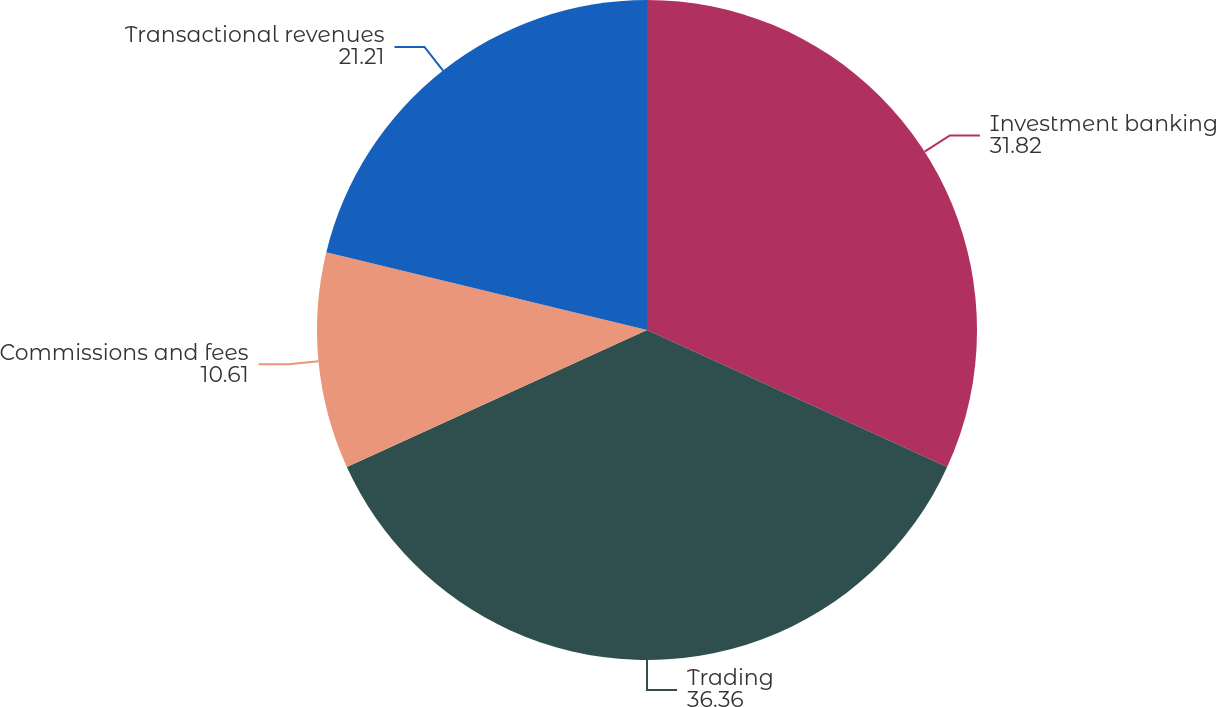Convert chart. <chart><loc_0><loc_0><loc_500><loc_500><pie_chart><fcel>Investment banking<fcel>Trading<fcel>Commissions and fees<fcel>Transactional revenues<nl><fcel>31.82%<fcel>36.36%<fcel>10.61%<fcel>21.21%<nl></chart> 